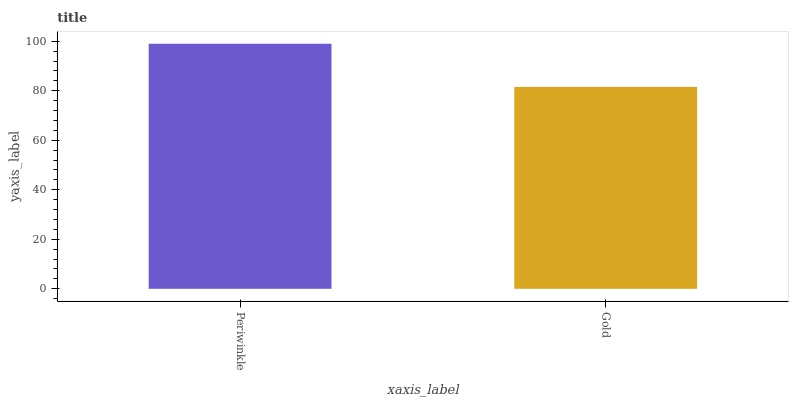Is Gold the maximum?
Answer yes or no. No. Is Periwinkle greater than Gold?
Answer yes or no. Yes. Is Gold less than Periwinkle?
Answer yes or no. Yes. Is Gold greater than Periwinkle?
Answer yes or no. No. Is Periwinkle less than Gold?
Answer yes or no. No. Is Periwinkle the high median?
Answer yes or no. Yes. Is Gold the low median?
Answer yes or no. Yes. Is Gold the high median?
Answer yes or no. No. Is Periwinkle the low median?
Answer yes or no. No. 